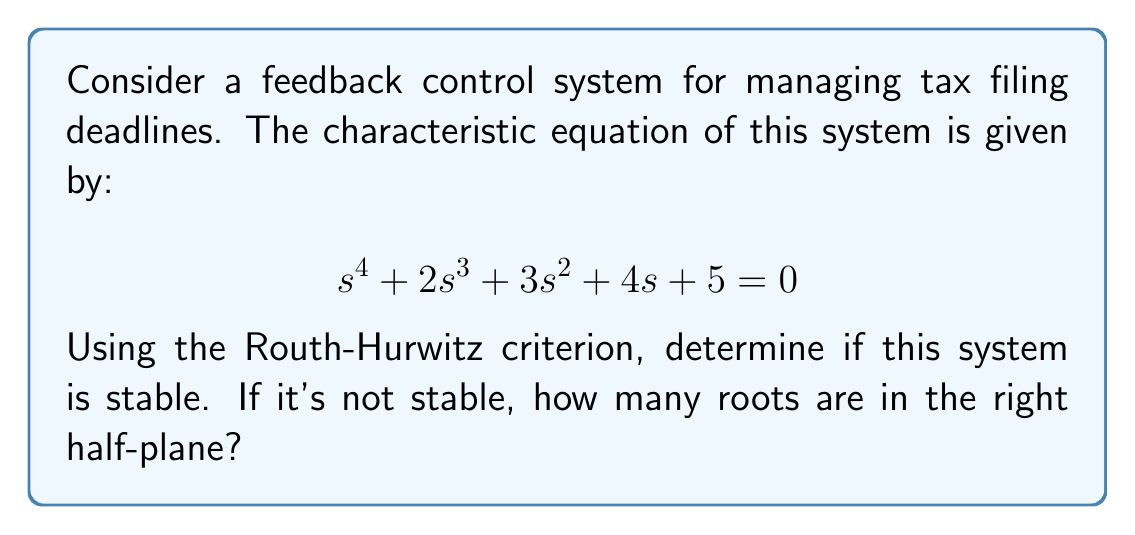Could you help me with this problem? To determine the stability of the system using the Routh-Hurwitz criterion, we need to construct the Routh array and analyze it. Let's go through this step-by-step:

1. Construct the Routh array:

   $$\begin{array}{c|cccc}
   s^4 & 1 & 3 & 5 \\
   s^3 & 2 & 4 & 0 \\
   s^2 & b_1 & b_2 & \\
   s^1 & c_1 & & \\
   s^0 & d_1 & &
   \end{array}$$

2. Calculate $b_1$:
   $$b_1 = \frac{(2 \times 3) - (1 \times 4)}{2} = \frac{6 - 4}{2} = 1$$

3. Calculate $b_2$:
   $$b_2 = \frac{(2 \times 5) - (1 \times 0)}{2} = \frac{10}{2} = 5$$

4. Calculate $c_1$:
   $$c_1 = \frac{(1 \times 4) - (2 \times 5)}{1} = 4 - 10 = -6$$

5. Calculate $d_1$:
   $$d_1 = \frac{(-6 \times 5) - (1 \times 0)}{-6} = 5$$

6. The complete Routh array:

   $$\begin{array}{c|cccc}
   s^4 & 1 & 3 & 5 \\
   s^3 & 2 & 4 & 0 \\
   s^2 & 1 & 5 & \\
   s^1 & -6 & & \\
   s^0 & 5 & &
   \end{array}$$

7. Analyze the signs in the first column:
   There is a sign change between $s^2$ and $s^1$ rows (from positive to negative).

According to the Routh-Hurwitz criterion, the number of sign changes in the first column of the Routh array equals the number of roots in the right half-plane. In this case, we have one sign change.

Therefore, the system is unstable, and there is one root in the right half-plane.
Answer: The system is unstable, with one root in the right half-plane. 